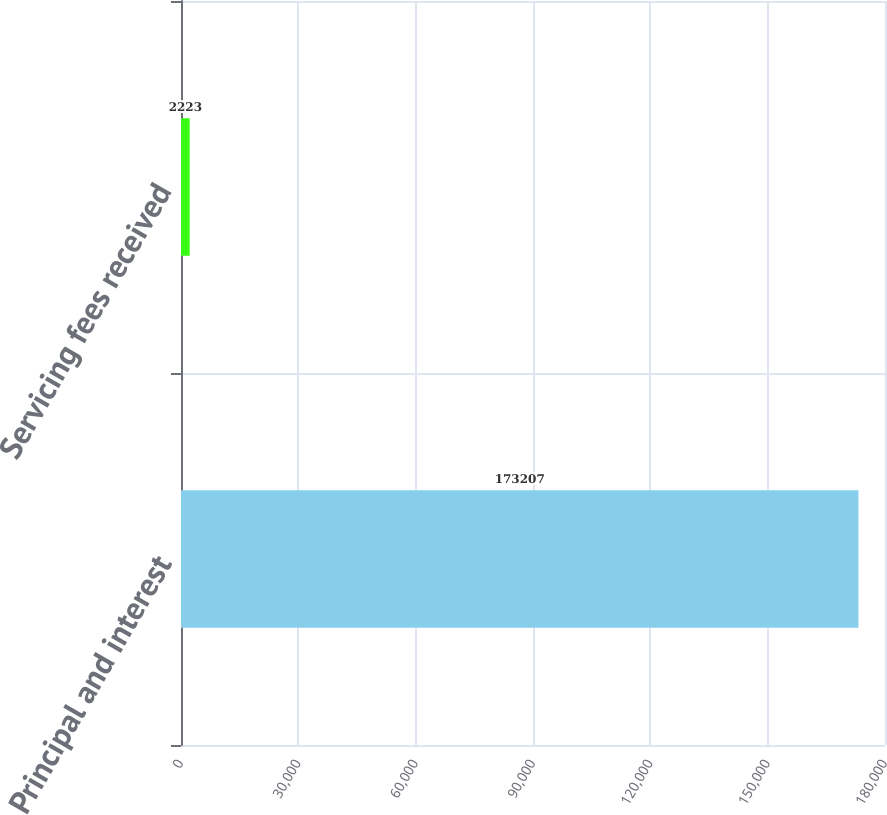Convert chart to OTSL. <chart><loc_0><loc_0><loc_500><loc_500><bar_chart><fcel>Principal and interest<fcel>Servicing fees received<nl><fcel>173207<fcel>2223<nl></chart> 